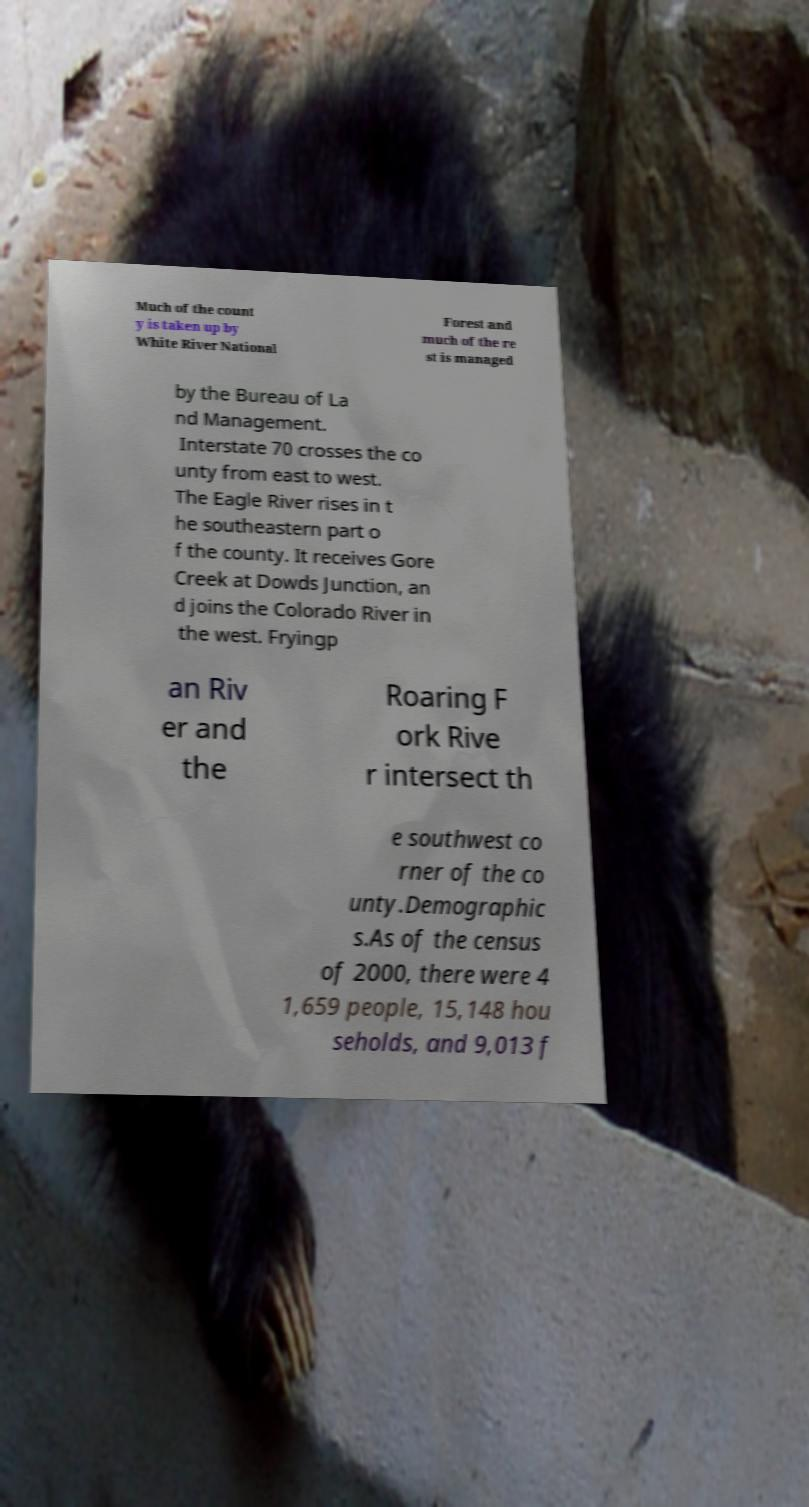I need the written content from this picture converted into text. Can you do that? Much of the count y is taken up by White River National Forest and much of the re st is managed by the Bureau of La nd Management. Interstate 70 crosses the co unty from east to west. The Eagle River rises in t he southeastern part o f the county. It receives Gore Creek at Dowds Junction, an d joins the Colorado River in the west. Fryingp an Riv er and the Roaring F ork Rive r intersect th e southwest co rner of the co unty.Demographic s.As of the census of 2000, there were 4 1,659 people, 15,148 hou seholds, and 9,013 f 